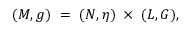Convert formula to latex. <formula><loc_0><loc_0><loc_500><loc_500>( M , g ) \ = \ ( N , \eta ) \, \times \, ( L , G ) ,</formula> 